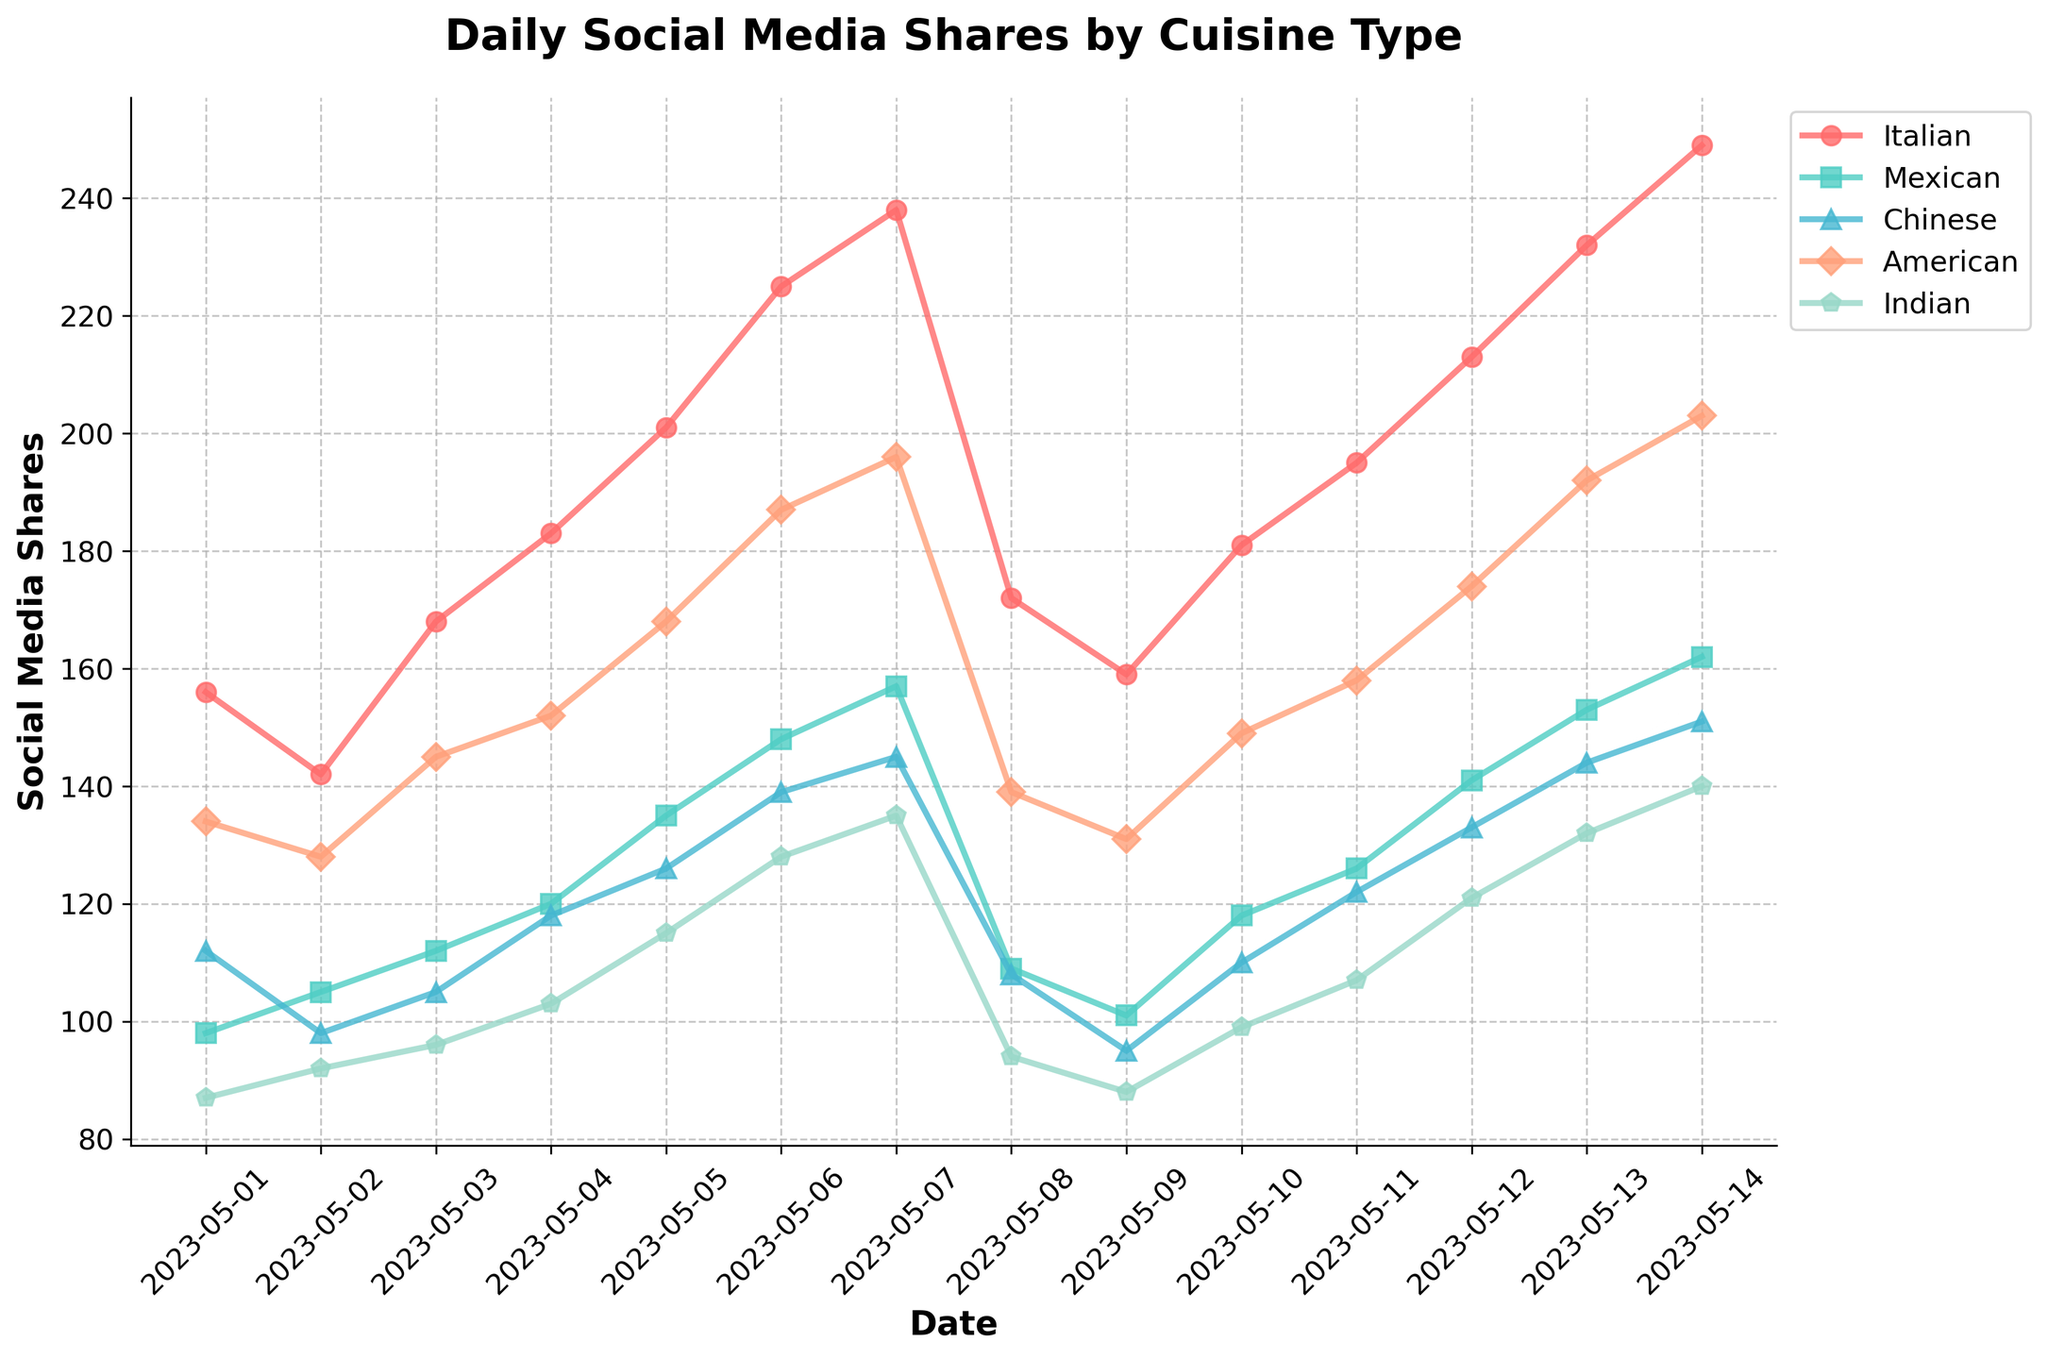What was the cuisine type with the highest number of social media shares on May 14, 2023? Look for the highest point in the figure on May 14, 2023, and identify the corresponding cuisine from the legend.
Answer: American How did the number of social media shares for Indian cuisine change from May 6 to May 7, 2023? Check the values on May 6 and May 7, 2023, for Indian cuisine and calculate the difference: (135 - 128). This involves a subtraction operation.
Answer: Increased by 7 Which cuisine had the lowest number of social media shares on May 8, 2023? Look at the values on May 8, 2023, for all cuisines and find the minimum value.
Answer: Indian Between May 1, 2023, and May 7, 2023, which cuisine showed the largest increase in social media shares? Calculate the difference in shares from May 1 to May 7, 2023, for all cuisines and identify the maximum increment. Compare each cuisine’s values: Italian (238-156), Mexican (157-98), Chinese (145-112), American (196-134), and Indian (135-87).
Answer: Italian What's the average number of social media shares for American cuisine from May 1, 2023, to May 14, 2023? Sum all shares for American cuisine from May 1 to May 14 and divide by the total days: (134 + 128 + 145 + 152 + 168 + 187 + 196 + 139 + 131 + 149 + 158 + 174 + 192 + 203)/14, which involves summing and division operations.
Answer: 162.14 Which cuisine experienced the steepest decline in social media shares after reaching its peak? Identify the peak value for each cuisine and then check the subsequent decline: Italian peaks on May 14 (249), Mexican on May 14 (162), Chinese on May 14 (151), American on May 14 (203), and Indian on May 14 (140). Compare the subsequent drop-off in values.
Answer: Italian On which date did all cuisines show an increase in social media shares compared to the previous day? Check daily increments for each cuisine and identify the common dates when all increments are positive. Specifically, look at May 4, May 5, and May 6 increments for all cuisines.
Answer: May 4, 2023 Compare the trends of Italian and Chinese cuisines from May 1, 2023, to May 14, 2023. Which one had more consistent shares over the period? Analyze the line chart for fluctuations. Italian shows a steady rise, but Chinese shows more irregular fluctuations. Italian’s line is smoother compared to Chinese.
Answer: Italian How does the total number of shares for Mexican cuisine from May 1 to May 7 compare to that from May 8 to May 14? Calculate the total shares for both periods and compare: Total from May 1 to May 7 (98 + 105 + 112 + 120 + 135 + 148 + 157) and May 8 to May 14 (109 + 101 + 118 + 126 + 141 + 153 + 162), then compare the sums.
Answer: May 8 to May 14 is higher Is there a date when the social media shares of Chinese cuisine were equal to that of Indian cuisine? Compare the daily shares of Chinese and Indian cuisines to find a match. Look for intersection points on the graph, particularly around similar levels. Both are equal on May 7 (145).
Answer: May 7, 2023 